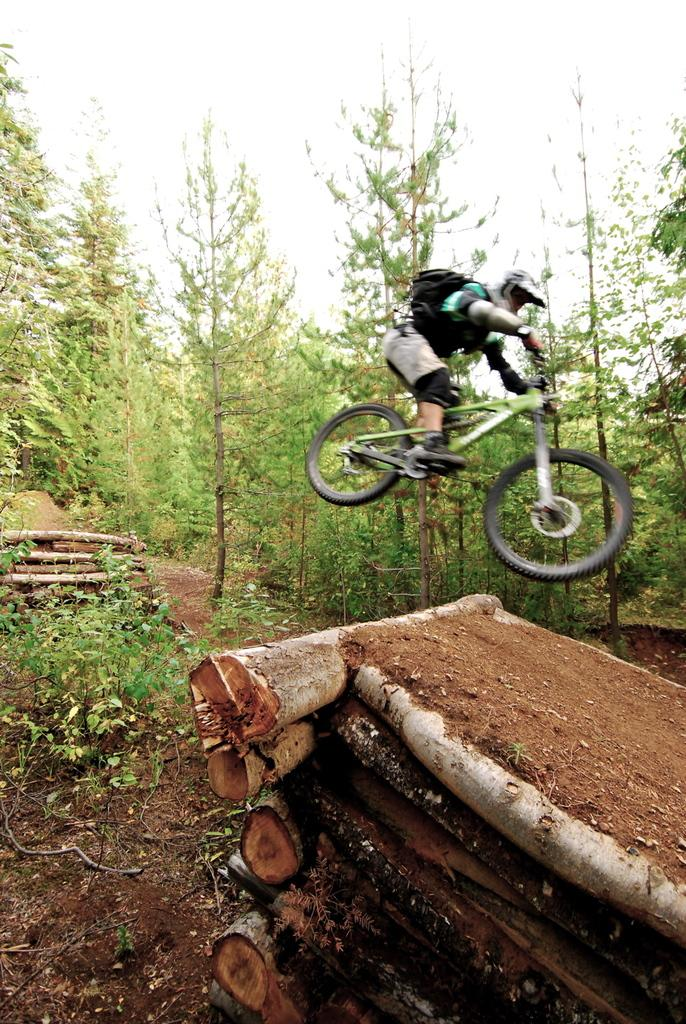What is the main subject of the image? There is a person in the image. What protective gear is the person wearing? The person is wearing a helmet. What type of footwear is the person wearing? The person is wearing shoes. What emotion does the person appear to be expressing? The person appears to be crying. What mode of transportation is the person using? The person is riding a bicycle. Is the bicycle on the ground or elevated? The bicycle is in the air. What type of material can be seen on the ground? There are wooden logs on the ground. What type of natural environment is visible in the image? There are trees in the image. What is visible in the background of the image? The sky is visible in the background. What type of trains can be seen in the image? There are no trains present in the image. What advice does the person's mom give them in the image? There is no reference to the person's mom or any advice in the image. 